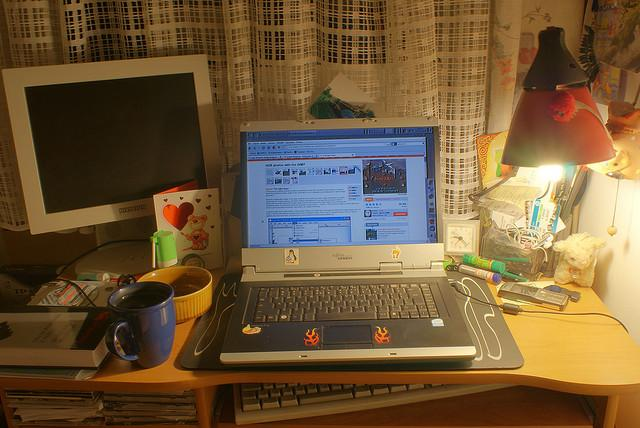How many keys are on a keyboard?

Choices:
A) 101
B) 112
C) 100
D) 110 101 